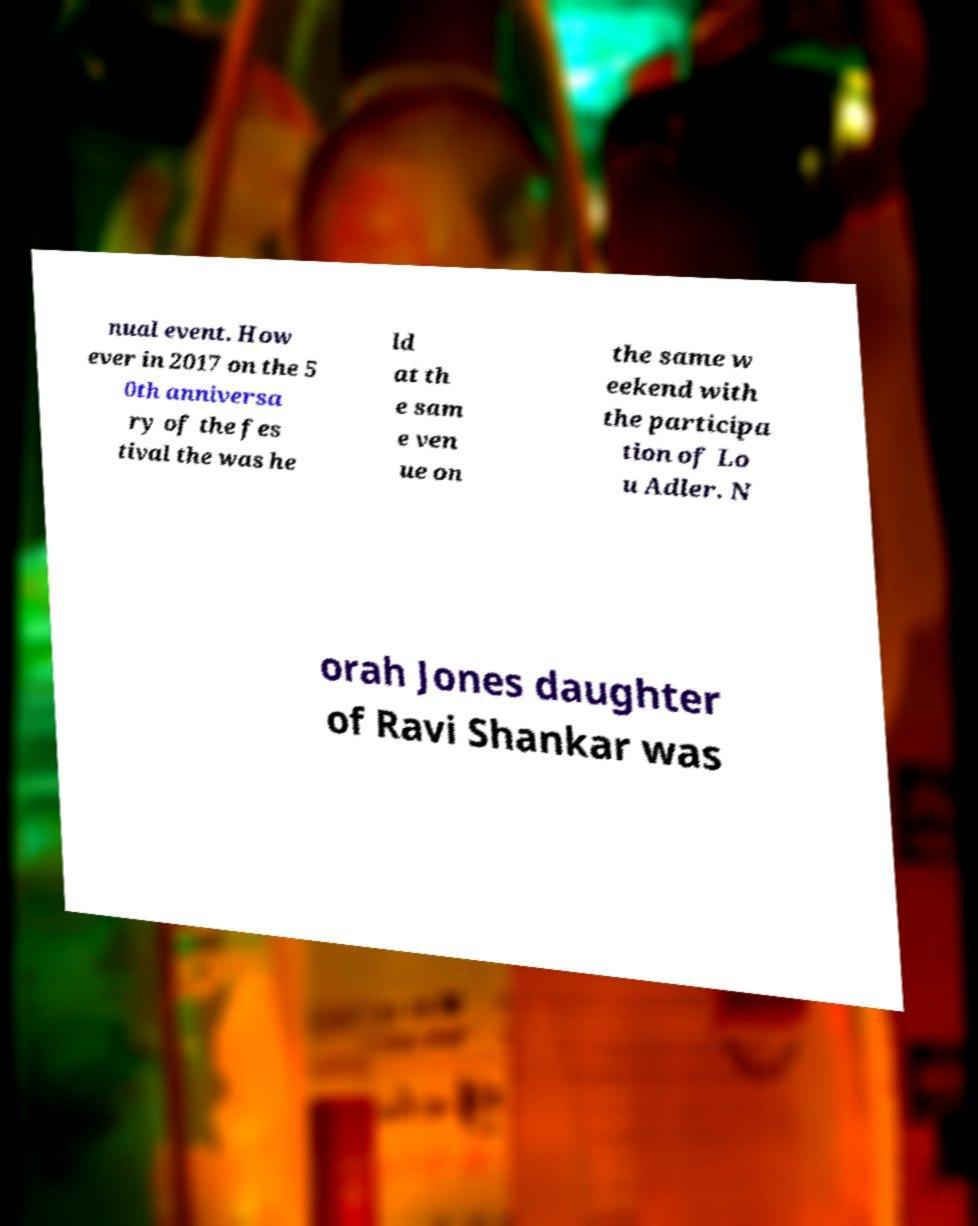Can you read and provide the text displayed in the image?This photo seems to have some interesting text. Can you extract and type it out for me? nual event. How ever in 2017 on the 5 0th anniversa ry of the fes tival the was he ld at th e sam e ven ue on the same w eekend with the participa tion of Lo u Adler. N orah Jones daughter of Ravi Shankar was 